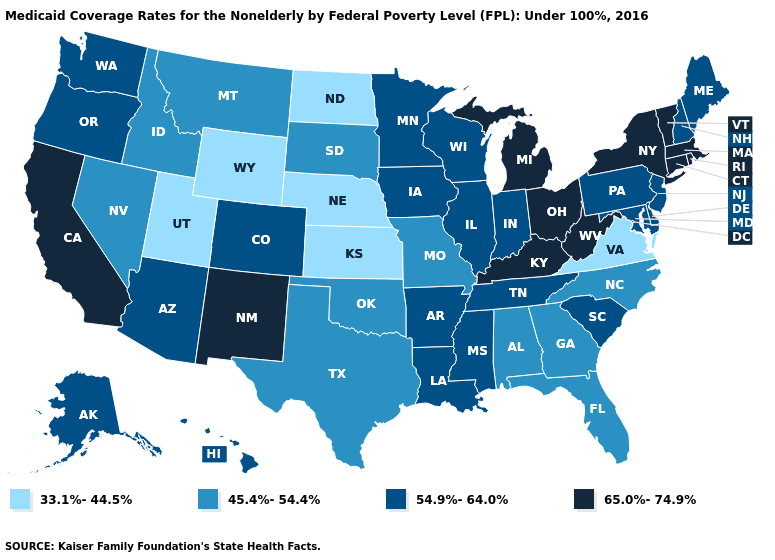Does Massachusetts have the same value as Kentucky?
Concise answer only. Yes. Does Texas have a higher value than Idaho?
Quick response, please. No. What is the value of Alabama?
Be succinct. 45.4%-54.4%. What is the value of Montana?
Answer briefly. 45.4%-54.4%. Is the legend a continuous bar?
Quick response, please. No. Among the states that border Montana , which have the lowest value?
Concise answer only. North Dakota, Wyoming. Name the states that have a value in the range 33.1%-44.5%?
Quick response, please. Kansas, Nebraska, North Dakota, Utah, Virginia, Wyoming. Name the states that have a value in the range 45.4%-54.4%?
Give a very brief answer. Alabama, Florida, Georgia, Idaho, Missouri, Montana, Nevada, North Carolina, Oklahoma, South Dakota, Texas. What is the highest value in the USA?
Concise answer only. 65.0%-74.9%. Does New Mexico have the highest value in the West?
Short answer required. Yes. Which states have the highest value in the USA?
Answer briefly. California, Connecticut, Kentucky, Massachusetts, Michigan, New Mexico, New York, Ohio, Rhode Island, Vermont, West Virginia. Does Alabama have the lowest value in the South?
Concise answer only. No. What is the value of Oregon?
Be succinct. 54.9%-64.0%. Which states have the highest value in the USA?
Keep it brief. California, Connecticut, Kentucky, Massachusetts, Michigan, New Mexico, New York, Ohio, Rhode Island, Vermont, West Virginia. Does Virginia have the lowest value in the South?
Short answer required. Yes. 